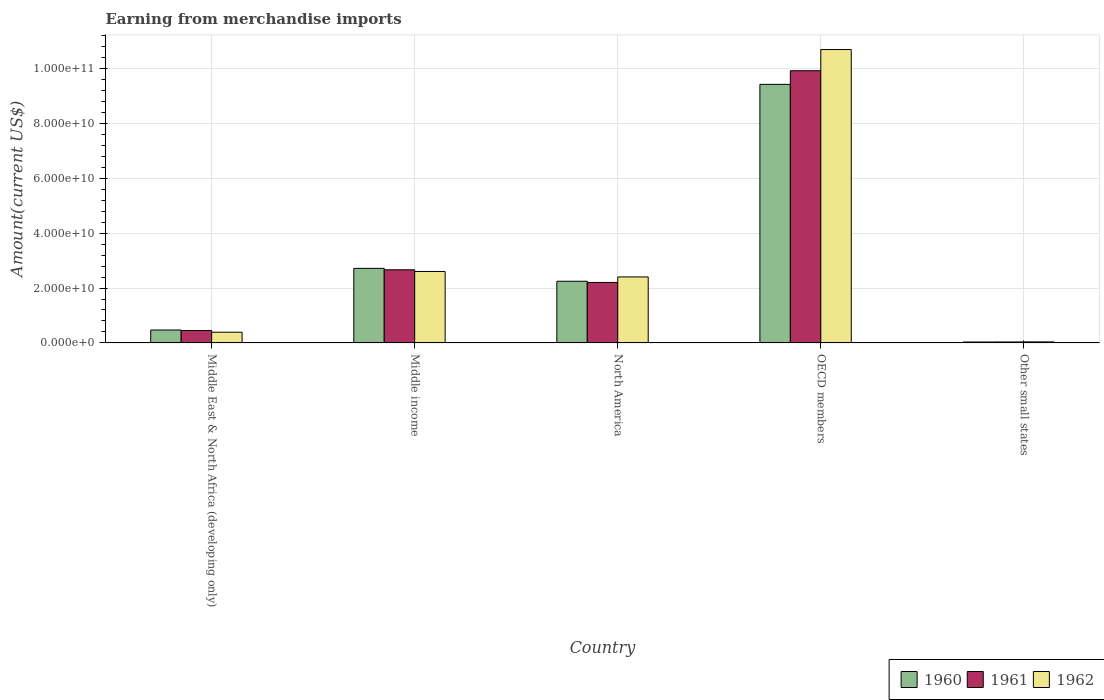How many different coloured bars are there?
Offer a very short reply. 3. Are the number of bars per tick equal to the number of legend labels?
Provide a short and direct response. Yes. How many bars are there on the 3rd tick from the left?
Provide a short and direct response. 3. What is the label of the 5th group of bars from the left?
Your response must be concise. Other small states. What is the amount earned from merchandise imports in 1961 in OECD members?
Your response must be concise. 9.92e+1. Across all countries, what is the maximum amount earned from merchandise imports in 1962?
Provide a succinct answer. 1.07e+11. Across all countries, what is the minimum amount earned from merchandise imports in 1960?
Make the answer very short. 3.42e+08. In which country was the amount earned from merchandise imports in 1961 maximum?
Make the answer very short. OECD members. In which country was the amount earned from merchandise imports in 1962 minimum?
Provide a short and direct response. Other small states. What is the total amount earned from merchandise imports in 1962 in the graph?
Your answer should be compact. 1.61e+11. What is the difference between the amount earned from merchandise imports in 1960 in North America and that in OECD members?
Offer a very short reply. -7.17e+1. What is the difference between the amount earned from merchandise imports in 1962 in Middle income and the amount earned from merchandise imports in 1961 in North America?
Provide a succinct answer. 3.99e+09. What is the average amount earned from merchandise imports in 1960 per country?
Keep it short and to the point. 2.98e+1. What is the difference between the amount earned from merchandise imports of/in 1960 and amount earned from merchandise imports of/in 1961 in Other small states?
Keep it short and to the point. -1.59e+07. What is the ratio of the amount earned from merchandise imports in 1961 in Middle East & North Africa (developing only) to that in Other small states?
Keep it short and to the point. 12.64. What is the difference between the highest and the second highest amount earned from merchandise imports in 1961?
Offer a very short reply. -7.25e+1. What is the difference between the highest and the lowest amount earned from merchandise imports in 1962?
Offer a very short reply. 1.06e+11. In how many countries, is the amount earned from merchandise imports in 1962 greater than the average amount earned from merchandise imports in 1962 taken over all countries?
Your answer should be compact. 1. What does the 3rd bar from the left in Middle income represents?
Ensure brevity in your answer.  1962. What does the 1st bar from the right in Middle East & North Africa (developing only) represents?
Your answer should be compact. 1962. How many bars are there?
Make the answer very short. 15. How many countries are there in the graph?
Your response must be concise. 5. Are the values on the major ticks of Y-axis written in scientific E-notation?
Provide a succinct answer. Yes. Does the graph contain any zero values?
Your response must be concise. No. Does the graph contain grids?
Your answer should be compact. Yes. How are the legend labels stacked?
Your answer should be very brief. Horizontal. What is the title of the graph?
Keep it short and to the point. Earning from merchandise imports. What is the label or title of the X-axis?
Offer a very short reply. Country. What is the label or title of the Y-axis?
Ensure brevity in your answer.  Amount(current US$). What is the Amount(current US$) of 1960 in Middle East & North Africa (developing only)?
Keep it short and to the point. 4.71e+09. What is the Amount(current US$) of 1961 in Middle East & North Africa (developing only)?
Give a very brief answer. 4.52e+09. What is the Amount(current US$) in 1962 in Middle East & North Africa (developing only)?
Your answer should be compact. 3.91e+09. What is the Amount(current US$) in 1960 in Middle income?
Provide a short and direct response. 2.72e+1. What is the Amount(current US$) in 1961 in Middle income?
Ensure brevity in your answer.  2.66e+1. What is the Amount(current US$) of 1962 in Middle income?
Provide a short and direct response. 2.60e+1. What is the Amount(current US$) in 1960 in North America?
Ensure brevity in your answer.  2.25e+1. What is the Amount(current US$) in 1961 in North America?
Keep it short and to the point. 2.20e+1. What is the Amount(current US$) in 1962 in North America?
Keep it short and to the point. 2.40e+1. What is the Amount(current US$) of 1960 in OECD members?
Make the answer very short. 9.42e+1. What is the Amount(current US$) in 1961 in OECD members?
Make the answer very short. 9.92e+1. What is the Amount(current US$) of 1962 in OECD members?
Make the answer very short. 1.07e+11. What is the Amount(current US$) of 1960 in Other small states?
Ensure brevity in your answer.  3.42e+08. What is the Amount(current US$) of 1961 in Other small states?
Keep it short and to the point. 3.58e+08. What is the Amount(current US$) in 1962 in Other small states?
Offer a very short reply. 3.80e+08. Across all countries, what is the maximum Amount(current US$) in 1960?
Provide a short and direct response. 9.42e+1. Across all countries, what is the maximum Amount(current US$) in 1961?
Ensure brevity in your answer.  9.92e+1. Across all countries, what is the maximum Amount(current US$) in 1962?
Offer a terse response. 1.07e+11. Across all countries, what is the minimum Amount(current US$) of 1960?
Provide a succinct answer. 3.42e+08. Across all countries, what is the minimum Amount(current US$) in 1961?
Your answer should be very brief. 3.58e+08. Across all countries, what is the minimum Amount(current US$) of 1962?
Ensure brevity in your answer.  3.80e+08. What is the total Amount(current US$) in 1960 in the graph?
Provide a succinct answer. 1.49e+11. What is the total Amount(current US$) in 1961 in the graph?
Your answer should be compact. 1.53e+11. What is the total Amount(current US$) in 1962 in the graph?
Offer a very short reply. 1.61e+11. What is the difference between the Amount(current US$) of 1960 in Middle East & North Africa (developing only) and that in Middle income?
Your response must be concise. -2.25e+1. What is the difference between the Amount(current US$) of 1961 in Middle East & North Africa (developing only) and that in Middle income?
Give a very brief answer. -2.21e+1. What is the difference between the Amount(current US$) of 1962 in Middle East & North Africa (developing only) and that in Middle income?
Offer a terse response. -2.21e+1. What is the difference between the Amount(current US$) of 1960 in Middle East & North Africa (developing only) and that in North America?
Your answer should be compact. -1.78e+1. What is the difference between the Amount(current US$) of 1961 in Middle East & North Africa (developing only) and that in North America?
Your response must be concise. -1.75e+1. What is the difference between the Amount(current US$) in 1962 in Middle East & North Africa (developing only) and that in North America?
Offer a very short reply. -2.01e+1. What is the difference between the Amount(current US$) of 1960 in Middle East & North Africa (developing only) and that in OECD members?
Your response must be concise. -8.95e+1. What is the difference between the Amount(current US$) in 1961 in Middle East & North Africa (developing only) and that in OECD members?
Provide a short and direct response. -9.46e+1. What is the difference between the Amount(current US$) of 1962 in Middle East & North Africa (developing only) and that in OECD members?
Keep it short and to the point. -1.03e+11. What is the difference between the Amount(current US$) in 1960 in Middle East & North Africa (developing only) and that in Other small states?
Give a very brief answer. 4.37e+09. What is the difference between the Amount(current US$) in 1961 in Middle East & North Africa (developing only) and that in Other small states?
Give a very brief answer. 4.16e+09. What is the difference between the Amount(current US$) of 1962 in Middle East & North Africa (developing only) and that in Other small states?
Offer a very short reply. 3.53e+09. What is the difference between the Amount(current US$) of 1960 in Middle income and that in North America?
Ensure brevity in your answer.  4.69e+09. What is the difference between the Amount(current US$) in 1961 in Middle income and that in North America?
Your answer should be compact. 4.61e+09. What is the difference between the Amount(current US$) of 1962 in Middle income and that in North America?
Offer a terse response. 1.98e+09. What is the difference between the Amount(current US$) in 1960 in Middle income and that in OECD members?
Offer a very short reply. -6.70e+1. What is the difference between the Amount(current US$) in 1961 in Middle income and that in OECD members?
Your answer should be compact. -7.25e+1. What is the difference between the Amount(current US$) in 1962 in Middle income and that in OECD members?
Offer a terse response. -8.08e+1. What is the difference between the Amount(current US$) of 1960 in Middle income and that in Other small states?
Provide a short and direct response. 2.68e+1. What is the difference between the Amount(current US$) in 1961 in Middle income and that in Other small states?
Provide a succinct answer. 2.63e+1. What is the difference between the Amount(current US$) of 1962 in Middle income and that in Other small states?
Keep it short and to the point. 2.56e+1. What is the difference between the Amount(current US$) in 1960 in North America and that in OECD members?
Ensure brevity in your answer.  -7.17e+1. What is the difference between the Amount(current US$) of 1961 in North America and that in OECD members?
Offer a terse response. -7.71e+1. What is the difference between the Amount(current US$) in 1962 in North America and that in OECD members?
Your answer should be very brief. -8.28e+1. What is the difference between the Amount(current US$) in 1960 in North America and that in Other small states?
Give a very brief answer. 2.21e+1. What is the difference between the Amount(current US$) in 1961 in North America and that in Other small states?
Make the answer very short. 2.17e+1. What is the difference between the Amount(current US$) in 1962 in North America and that in Other small states?
Your answer should be compact. 2.37e+1. What is the difference between the Amount(current US$) of 1960 in OECD members and that in Other small states?
Your answer should be very brief. 9.38e+1. What is the difference between the Amount(current US$) of 1961 in OECD members and that in Other small states?
Your answer should be compact. 9.88e+1. What is the difference between the Amount(current US$) in 1962 in OECD members and that in Other small states?
Provide a succinct answer. 1.06e+11. What is the difference between the Amount(current US$) in 1960 in Middle East & North Africa (developing only) and the Amount(current US$) in 1961 in Middle income?
Offer a very short reply. -2.19e+1. What is the difference between the Amount(current US$) in 1960 in Middle East & North Africa (developing only) and the Amount(current US$) in 1962 in Middle income?
Provide a short and direct response. -2.13e+1. What is the difference between the Amount(current US$) of 1961 in Middle East & North Africa (developing only) and the Amount(current US$) of 1962 in Middle income?
Provide a succinct answer. -2.15e+1. What is the difference between the Amount(current US$) of 1960 in Middle East & North Africa (developing only) and the Amount(current US$) of 1961 in North America?
Provide a succinct answer. -1.73e+1. What is the difference between the Amount(current US$) of 1960 in Middle East & North Africa (developing only) and the Amount(current US$) of 1962 in North America?
Ensure brevity in your answer.  -1.93e+1. What is the difference between the Amount(current US$) of 1961 in Middle East & North Africa (developing only) and the Amount(current US$) of 1962 in North America?
Your answer should be compact. -1.95e+1. What is the difference between the Amount(current US$) in 1960 in Middle East & North Africa (developing only) and the Amount(current US$) in 1961 in OECD members?
Your answer should be compact. -9.44e+1. What is the difference between the Amount(current US$) of 1960 in Middle East & North Africa (developing only) and the Amount(current US$) of 1962 in OECD members?
Keep it short and to the point. -1.02e+11. What is the difference between the Amount(current US$) in 1961 in Middle East & North Africa (developing only) and the Amount(current US$) in 1962 in OECD members?
Provide a short and direct response. -1.02e+11. What is the difference between the Amount(current US$) in 1960 in Middle East & North Africa (developing only) and the Amount(current US$) in 1961 in Other small states?
Your answer should be very brief. 4.35e+09. What is the difference between the Amount(current US$) in 1960 in Middle East & North Africa (developing only) and the Amount(current US$) in 1962 in Other small states?
Your answer should be very brief. 4.33e+09. What is the difference between the Amount(current US$) of 1961 in Middle East & North Africa (developing only) and the Amount(current US$) of 1962 in Other small states?
Ensure brevity in your answer.  4.14e+09. What is the difference between the Amount(current US$) of 1960 in Middle income and the Amount(current US$) of 1961 in North America?
Your answer should be very brief. 5.13e+09. What is the difference between the Amount(current US$) of 1960 in Middle income and the Amount(current US$) of 1962 in North America?
Your answer should be compact. 3.12e+09. What is the difference between the Amount(current US$) in 1961 in Middle income and the Amount(current US$) in 1962 in North America?
Make the answer very short. 2.60e+09. What is the difference between the Amount(current US$) of 1960 in Middle income and the Amount(current US$) of 1961 in OECD members?
Offer a very short reply. -7.20e+1. What is the difference between the Amount(current US$) in 1960 in Middle income and the Amount(current US$) in 1962 in OECD members?
Make the answer very short. -7.97e+1. What is the difference between the Amount(current US$) in 1961 in Middle income and the Amount(current US$) in 1962 in OECD members?
Provide a succinct answer. -8.02e+1. What is the difference between the Amount(current US$) in 1960 in Middle income and the Amount(current US$) in 1961 in Other small states?
Your answer should be compact. 2.68e+1. What is the difference between the Amount(current US$) of 1960 in Middle income and the Amount(current US$) of 1962 in Other small states?
Keep it short and to the point. 2.68e+1. What is the difference between the Amount(current US$) in 1961 in Middle income and the Amount(current US$) in 1962 in Other small states?
Your answer should be very brief. 2.63e+1. What is the difference between the Amount(current US$) of 1960 in North America and the Amount(current US$) of 1961 in OECD members?
Your response must be concise. -7.67e+1. What is the difference between the Amount(current US$) in 1960 in North America and the Amount(current US$) in 1962 in OECD members?
Offer a very short reply. -8.44e+1. What is the difference between the Amount(current US$) of 1961 in North America and the Amount(current US$) of 1962 in OECD members?
Ensure brevity in your answer.  -8.48e+1. What is the difference between the Amount(current US$) in 1960 in North America and the Amount(current US$) in 1961 in Other small states?
Your answer should be very brief. 2.21e+1. What is the difference between the Amount(current US$) of 1960 in North America and the Amount(current US$) of 1962 in Other small states?
Your response must be concise. 2.21e+1. What is the difference between the Amount(current US$) of 1961 in North America and the Amount(current US$) of 1962 in Other small states?
Offer a terse response. 2.17e+1. What is the difference between the Amount(current US$) of 1960 in OECD members and the Amount(current US$) of 1961 in Other small states?
Offer a terse response. 9.38e+1. What is the difference between the Amount(current US$) in 1960 in OECD members and the Amount(current US$) in 1962 in Other small states?
Offer a very short reply. 9.38e+1. What is the difference between the Amount(current US$) in 1961 in OECD members and the Amount(current US$) in 1962 in Other small states?
Provide a short and direct response. 9.88e+1. What is the average Amount(current US$) in 1960 per country?
Provide a succinct answer. 2.98e+1. What is the average Amount(current US$) of 1961 per country?
Make the answer very short. 3.05e+1. What is the average Amount(current US$) in 1962 per country?
Give a very brief answer. 3.22e+1. What is the difference between the Amount(current US$) in 1960 and Amount(current US$) in 1961 in Middle East & North Africa (developing only)?
Your answer should be very brief. 1.90e+08. What is the difference between the Amount(current US$) of 1960 and Amount(current US$) of 1962 in Middle East & North Africa (developing only)?
Keep it short and to the point. 8.01e+08. What is the difference between the Amount(current US$) of 1961 and Amount(current US$) of 1962 in Middle East & North Africa (developing only)?
Your answer should be compact. 6.11e+08. What is the difference between the Amount(current US$) of 1960 and Amount(current US$) of 1961 in Middle income?
Give a very brief answer. 5.26e+08. What is the difference between the Amount(current US$) of 1960 and Amount(current US$) of 1962 in Middle income?
Provide a succinct answer. 1.14e+09. What is the difference between the Amount(current US$) in 1961 and Amount(current US$) in 1962 in Middle income?
Offer a terse response. 6.15e+08. What is the difference between the Amount(current US$) in 1960 and Amount(current US$) in 1961 in North America?
Ensure brevity in your answer.  4.40e+08. What is the difference between the Amount(current US$) in 1960 and Amount(current US$) in 1962 in North America?
Offer a terse response. -1.57e+09. What is the difference between the Amount(current US$) in 1961 and Amount(current US$) in 1962 in North America?
Offer a terse response. -2.01e+09. What is the difference between the Amount(current US$) in 1960 and Amount(current US$) in 1961 in OECD members?
Your answer should be compact. -4.97e+09. What is the difference between the Amount(current US$) in 1960 and Amount(current US$) in 1962 in OECD members?
Give a very brief answer. -1.27e+1. What is the difference between the Amount(current US$) of 1961 and Amount(current US$) of 1962 in OECD members?
Ensure brevity in your answer.  -7.71e+09. What is the difference between the Amount(current US$) of 1960 and Amount(current US$) of 1961 in Other small states?
Give a very brief answer. -1.59e+07. What is the difference between the Amount(current US$) of 1960 and Amount(current US$) of 1962 in Other small states?
Provide a succinct answer. -3.87e+07. What is the difference between the Amount(current US$) of 1961 and Amount(current US$) of 1962 in Other small states?
Make the answer very short. -2.28e+07. What is the ratio of the Amount(current US$) of 1960 in Middle East & North Africa (developing only) to that in Middle income?
Offer a very short reply. 0.17. What is the ratio of the Amount(current US$) of 1961 in Middle East & North Africa (developing only) to that in Middle income?
Keep it short and to the point. 0.17. What is the ratio of the Amount(current US$) of 1962 in Middle East & North Africa (developing only) to that in Middle income?
Offer a very short reply. 0.15. What is the ratio of the Amount(current US$) of 1960 in Middle East & North Africa (developing only) to that in North America?
Your response must be concise. 0.21. What is the ratio of the Amount(current US$) of 1961 in Middle East & North Africa (developing only) to that in North America?
Provide a short and direct response. 0.21. What is the ratio of the Amount(current US$) of 1962 in Middle East & North Africa (developing only) to that in North America?
Provide a short and direct response. 0.16. What is the ratio of the Amount(current US$) in 1960 in Middle East & North Africa (developing only) to that in OECD members?
Your answer should be very brief. 0.05. What is the ratio of the Amount(current US$) in 1961 in Middle East & North Africa (developing only) to that in OECD members?
Your response must be concise. 0.05. What is the ratio of the Amount(current US$) of 1962 in Middle East & North Africa (developing only) to that in OECD members?
Your response must be concise. 0.04. What is the ratio of the Amount(current US$) in 1960 in Middle East & North Africa (developing only) to that in Other small states?
Keep it short and to the point. 13.79. What is the ratio of the Amount(current US$) of 1961 in Middle East & North Africa (developing only) to that in Other small states?
Offer a terse response. 12.64. What is the ratio of the Amount(current US$) of 1962 in Middle East & North Africa (developing only) to that in Other small states?
Your answer should be very brief. 10.28. What is the ratio of the Amount(current US$) in 1960 in Middle income to that in North America?
Offer a terse response. 1.21. What is the ratio of the Amount(current US$) of 1961 in Middle income to that in North America?
Your response must be concise. 1.21. What is the ratio of the Amount(current US$) in 1962 in Middle income to that in North America?
Keep it short and to the point. 1.08. What is the ratio of the Amount(current US$) in 1960 in Middle income to that in OECD members?
Offer a terse response. 0.29. What is the ratio of the Amount(current US$) of 1961 in Middle income to that in OECD members?
Offer a very short reply. 0.27. What is the ratio of the Amount(current US$) in 1962 in Middle income to that in OECD members?
Offer a very short reply. 0.24. What is the ratio of the Amount(current US$) in 1960 in Middle income to that in Other small states?
Keep it short and to the point. 79.51. What is the ratio of the Amount(current US$) in 1961 in Middle income to that in Other small states?
Offer a very short reply. 74.5. What is the ratio of the Amount(current US$) of 1962 in Middle income to that in Other small states?
Offer a terse response. 68.41. What is the ratio of the Amount(current US$) in 1960 in North America to that in OECD members?
Your response must be concise. 0.24. What is the ratio of the Amount(current US$) in 1961 in North America to that in OECD members?
Provide a short and direct response. 0.22. What is the ratio of the Amount(current US$) in 1962 in North America to that in OECD members?
Ensure brevity in your answer.  0.23. What is the ratio of the Amount(current US$) of 1960 in North America to that in Other small states?
Offer a terse response. 65.77. What is the ratio of the Amount(current US$) in 1961 in North America to that in Other small states?
Your answer should be very brief. 61.62. What is the ratio of the Amount(current US$) in 1962 in North America to that in Other small states?
Your response must be concise. 63.2. What is the ratio of the Amount(current US$) in 1960 in OECD members to that in Other small states?
Your answer should be compact. 275.63. What is the ratio of the Amount(current US$) in 1961 in OECD members to that in Other small states?
Your answer should be compact. 277.27. What is the ratio of the Amount(current US$) in 1962 in OECD members to that in Other small states?
Ensure brevity in your answer.  280.88. What is the difference between the highest and the second highest Amount(current US$) of 1960?
Ensure brevity in your answer.  6.70e+1. What is the difference between the highest and the second highest Amount(current US$) of 1961?
Your answer should be compact. 7.25e+1. What is the difference between the highest and the second highest Amount(current US$) of 1962?
Offer a very short reply. 8.08e+1. What is the difference between the highest and the lowest Amount(current US$) in 1960?
Make the answer very short. 9.38e+1. What is the difference between the highest and the lowest Amount(current US$) of 1961?
Offer a very short reply. 9.88e+1. What is the difference between the highest and the lowest Amount(current US$) of 1962?
Provide a succinct answer. 1.06e+11. 